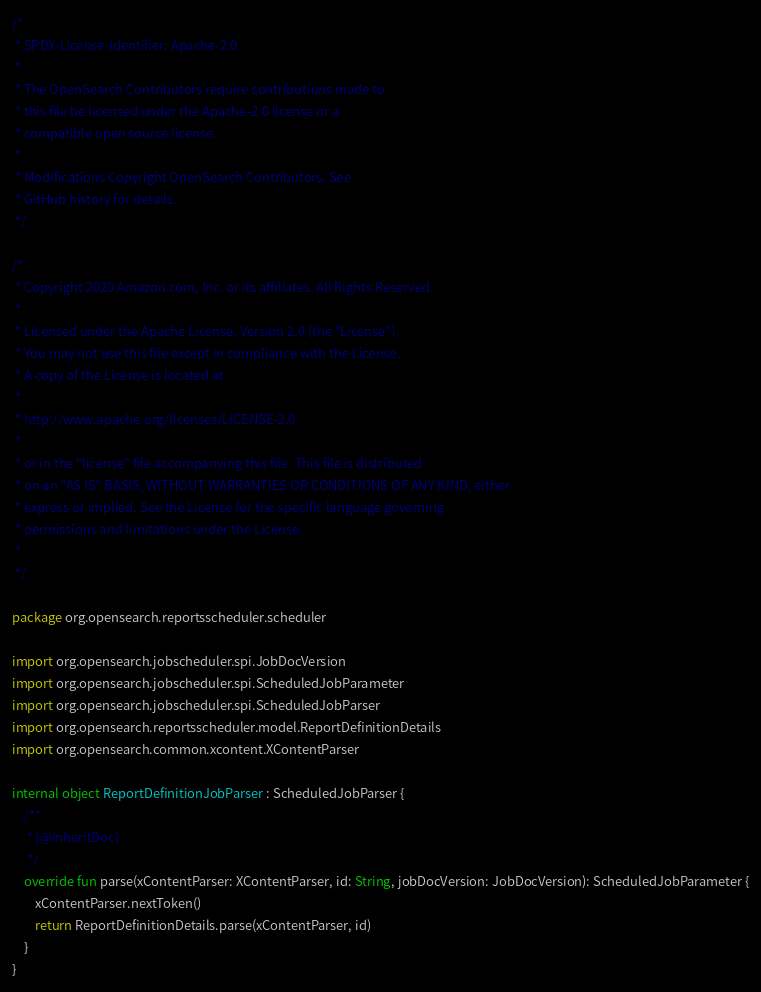<code> <loc_0><loc_0><loc_500><loc_500><_Kotlin_>/*
 * SPDX-License-Identifier: Apache-2.0
 *
 * The OpenSearch Contributors require contributions made to
 * this file be licensed under the Apache-2.0 license or a
 * compatible open source license.
 *
 * Modifications Copyright OpenSearch Contributors. See
 * GitHub history for details.
 */

/*
 * Copyright 2020 Amazon.com, Inc. or its affiliates. All Rights Reserved.
 *
 * Licensed under the Apache License, Version 2.0 (the "License").
 * You may not use this file except in compliance with the License.
 * A copy of the License is located at
 *
 * http://www.apache.org/licenses/LICENSE-2.0
 *
 * or in the "license" file accompanying this file. This file is distributed
 * on an "AS IS" BASIS, WITHOUT WARRANTIES OR CONDITIONS OF ANY KIND, either
 * express or implied. See the License for the specific language governing
 * permissions and limitations under the License.
 *
 */

package org.opensearch.reportsscheduler.scheduler

import org.opensearch.jobscheduler.spi.JobDocVersion
import org.opensearch.jobscheduler.spi.ScheduledJobParameter
import org.opensearch.jobscheduler.spi.ScheduledJobParser
import org.opensearch.reportsscheduler.model.ReportDefinitionDetails
import org.opensearch.common.xcontent.XContentParser

internal object ReportDefinitionJobParser : ScheduledJobParser {
    /**
     * {@inheritDoc}
     */
    override fun parse(xContentParser: XContentParser, id: String, jobDocVersion: JobDocVersion): ScheduledJobParameter {
        xContentParser.nextToken()
        return ReportDefinitionDetails.parse(xContentParser, id)
    }
}
</code> 